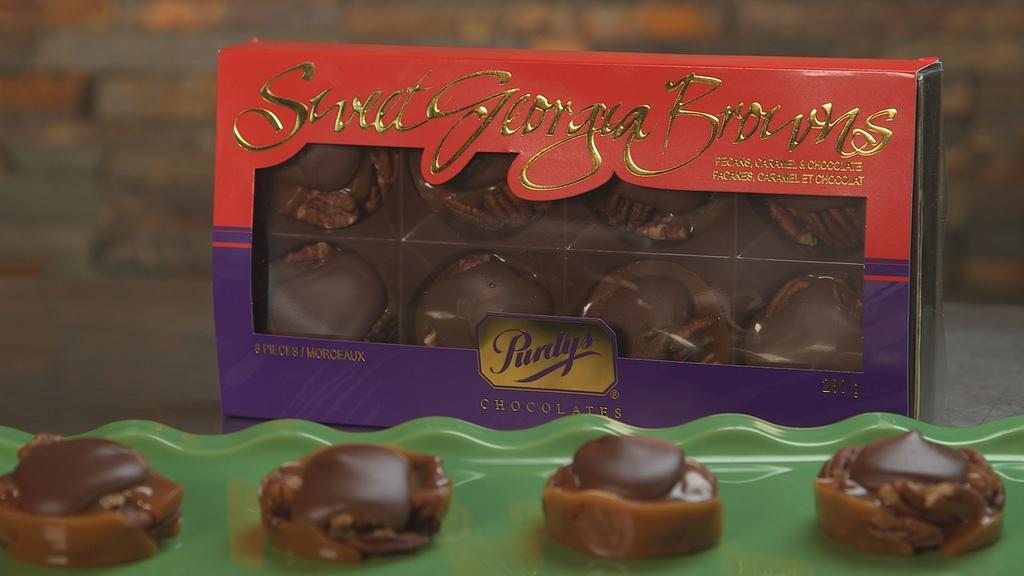What type of food is visible on the tray in the image? There are chocolates placed on a tray in the image. Are there any other containers for chocolates in the image? Yes, there are chocolates placed in a box in the image. What is the rate of expansion of the chocolates in the image? There is no information about the rate of expansion of the chocolates in the image. 